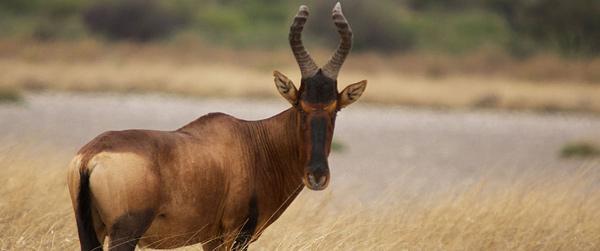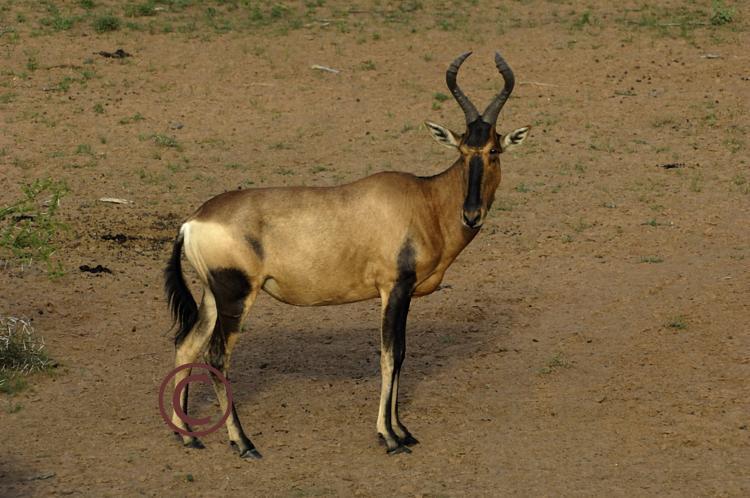The first image is the image on the left, the second image is the image on the right. For the images shown, is this caption "There are two antelopes in the image pair, both facing right." true? Answer yes or no. Yes. The first image is the image on the left, the second image is the image on the right. Evaluate the accuracy of this statement regarding the images: "One hooved animal has its body turned rightward and head facing forward, and the other stands with head and body in profile.". Is it true? Answer yes or no. No. 